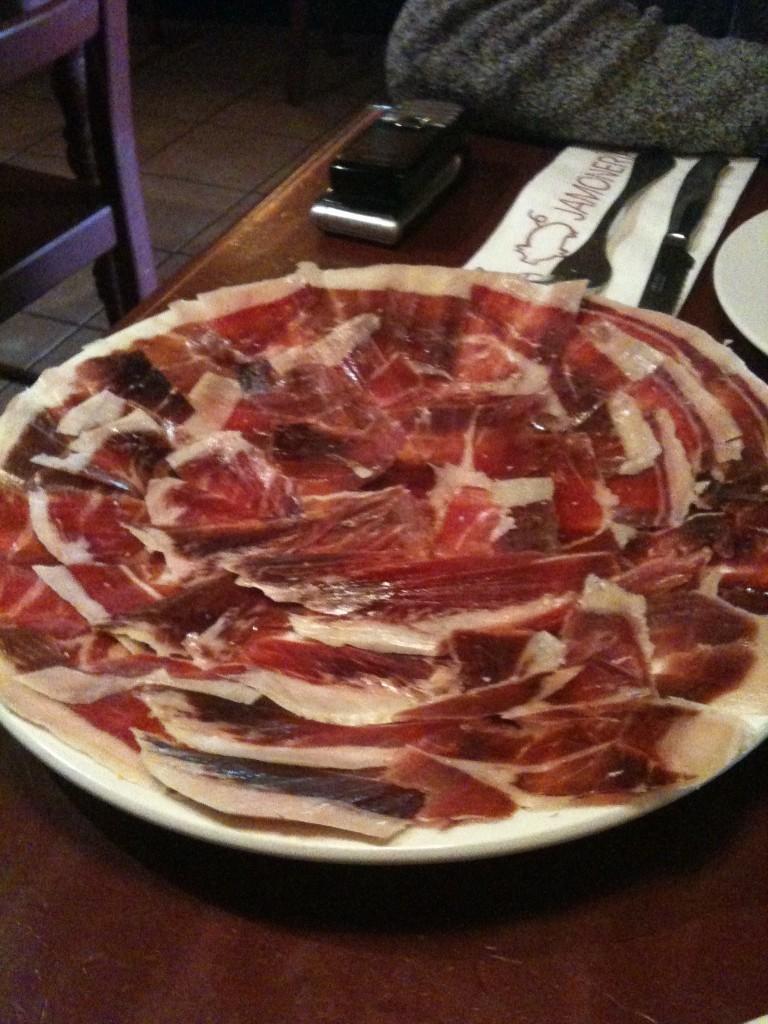Describe this image in one or two sentences. This is a table. This is a plate with some food. These are knife,fork,cell phones placed on the table. This looks like a chair. 